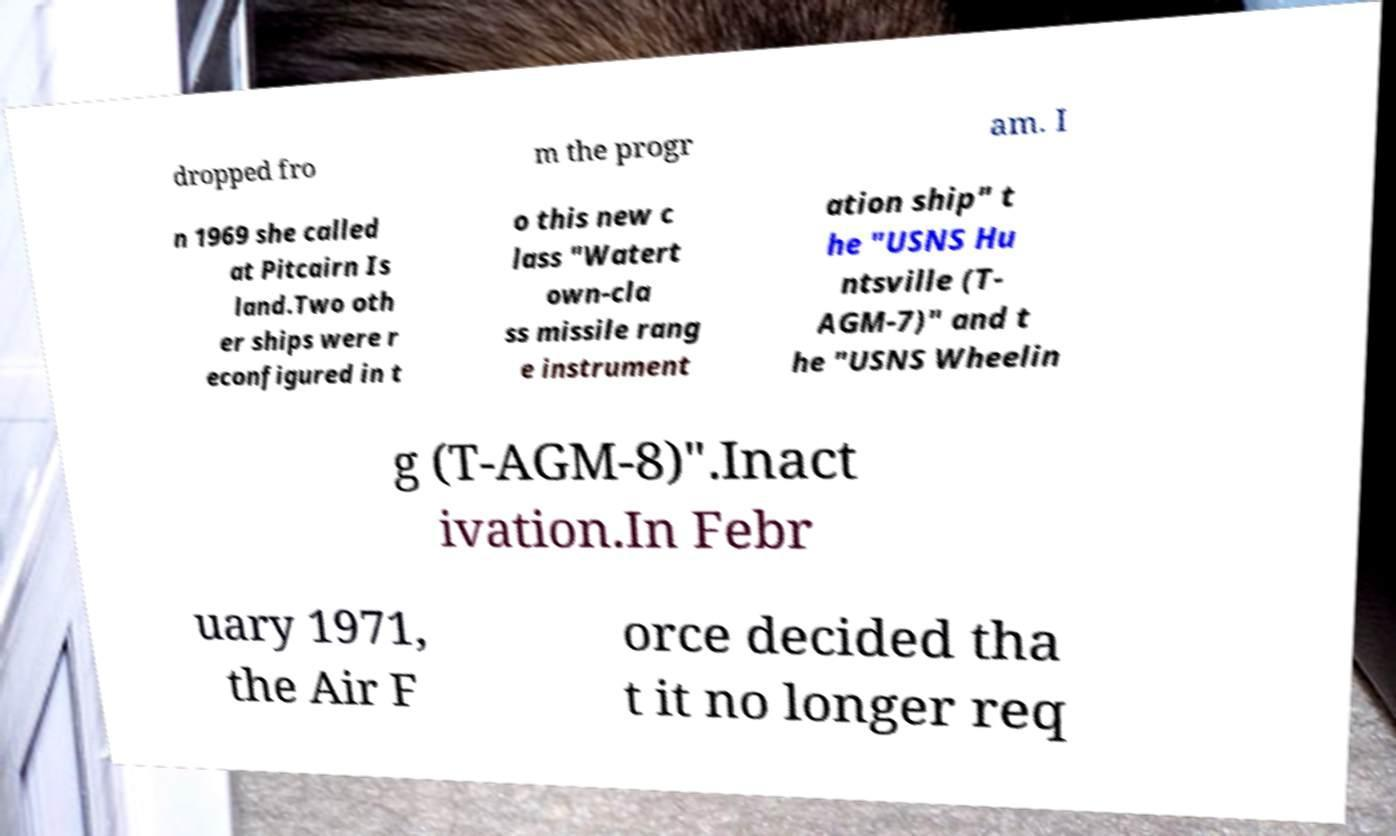Could you assist in decoding the text presented in this image and type it out clearly? dropped fro m the progr am. I n 1969 she called at Pitcairn Is land.Two oth er ships were r econfigured in t o this new c lass "Watert own-cla ss missile rang e instrument ation ship" t he "USNS Hu ntsville (T- AGM-7)" and t he "USNS Wheelin g (T-AGM-8)".Inact ivation.In Febr uary 1971, the Air F orce decided tha t it no longer req 